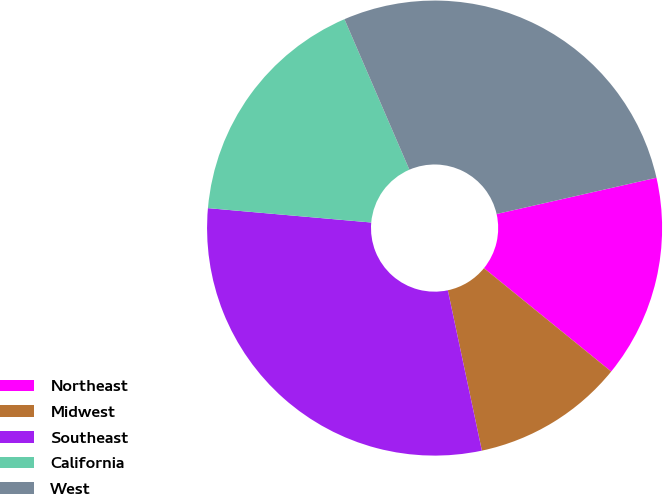Convert chart to OTSL. <chart><loc_0><loc_0><loc_500><loc_500><pie_chart><fcel>Northeast<fcel>Midwest<fcel>Southeast<fcel>California<fcel>West<nl><fcel>14.41%<fcel>10.81%<fcel>29.73%<fcel>17.12%<fcel>27.93%<nl></chart> 